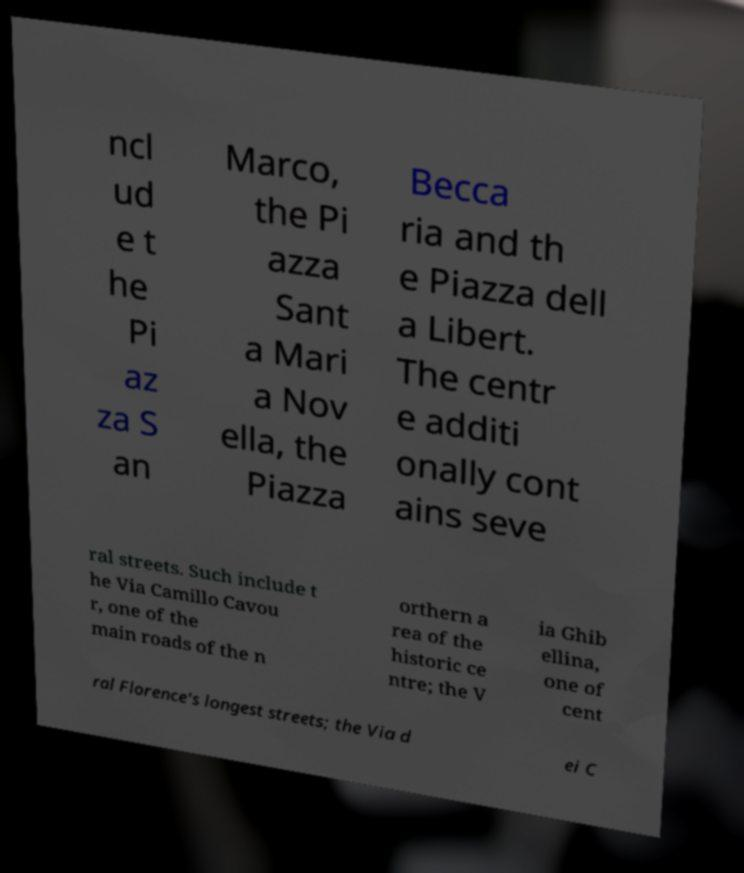For documentation purposes, I need the text within this image transcribed. Could you provide that? ncl ud e t he Pi az za S an Marco, the Pi azza Sant a Mari a Nov ella, the Piazza Becca ria and th e Piazza dell a Libert. The centr e additi onally cont ains seve ral streets. Such include t he Via Camillo Cavou r, one of the main roads of the n orthern a rea of the historic ce ntre; the V ia Ghib ellina, one of cent ral Florence's longest streets; the Via d ei C 